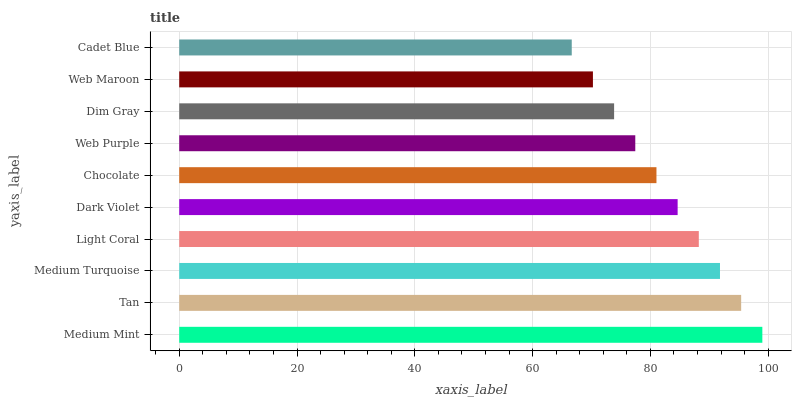Is Cadet Blue the minimum?
Answer yes or no. Yes. Is Medium Mint the maximum?
Answer yes or no. Yes. Is Tan the minimum?
Answer yes or no. No. Is Tan the maximum?
Answer yes or no. No. Is Medium Mint greater than Tan?
Answer yes or no. Yes. Is Tan less than Medium Mint?
Answer yes or no. Yes. Is Tan greater than Medium Mint?
Answer yes or no. No. Is Medium Mint less than Tan?
Answer yes or no. No. Is Dark Violet the high median?
Answer yes or no. Yes. Is Chocolate the low median?
Answer yes or no. Yes. Is Web Maroon the high median?
Answer yes or no. No. Is Dim Gray the low median?
Answer yes or no. No. 